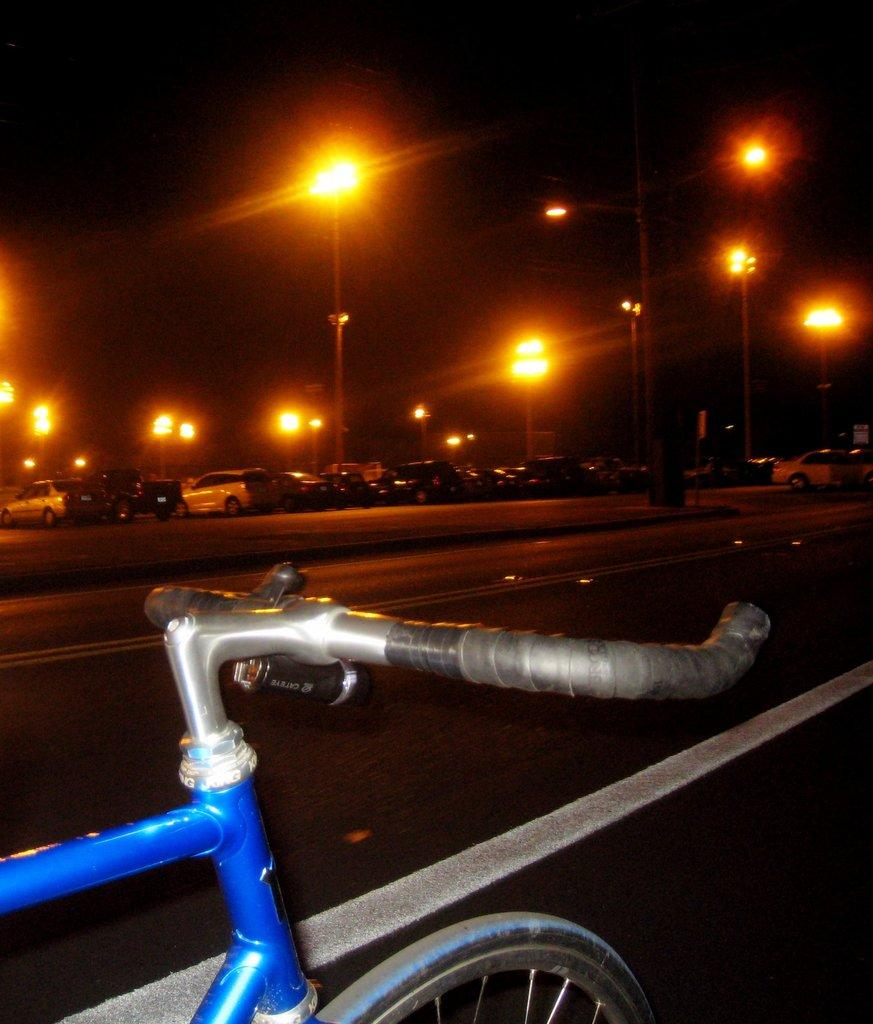What can be seen on the road in the image? There are vehicles parked on the road in the image. What else is present in the image besides the parked vehicles? There are street poles in the image. What is visible in the background of the image? The sky is visible in the image. What type of transportation can be seen in the foreground of the image? There is a bicycle in the foreground of the image. What type of stem can be seen growing from the bicycle in the image? There is no stem growing from the bicycle in the image. How does the surprise appear in the image? There is no surprise present in the image; it is a scene of parked vehicles, street poles, the sky, and a bicycle. 